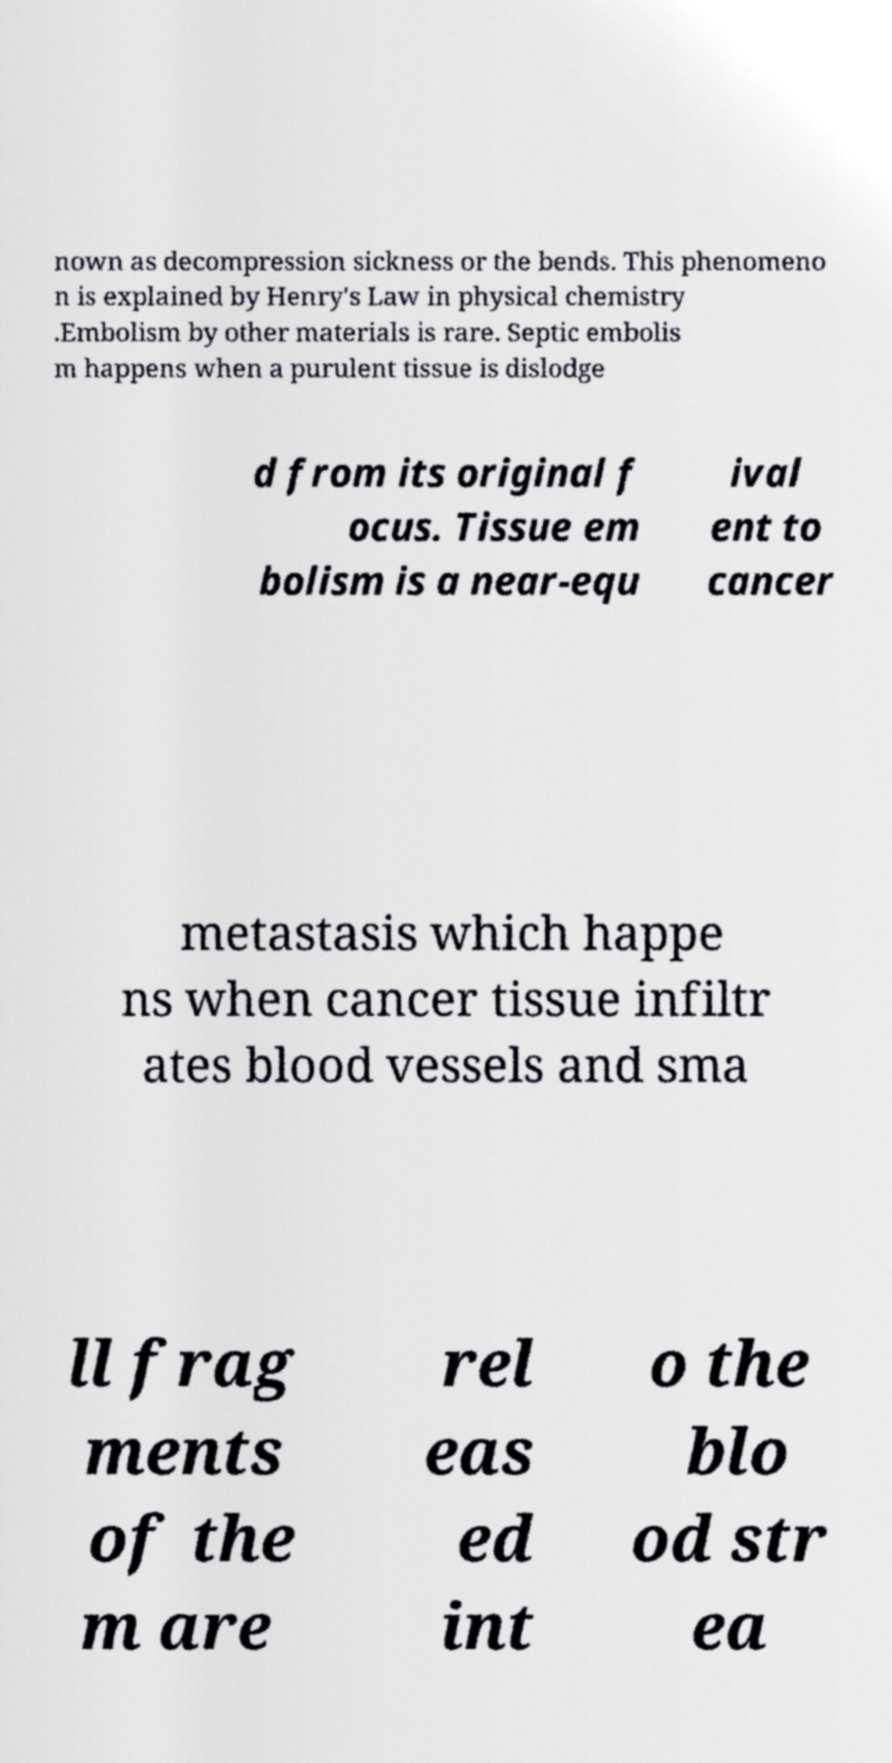What messages or text are displayed in this image? I need them in a readable, typed format. nown as decompression sickness or the bends. This phenomeno n is explained by Henry's Law in physical chemistry .Embolism by other materials is rare. Septic embolis m happens when a purulent tissue is dislodge d from its original f ocus. Tissue em bolism is a near-equ ival ent to cancer metastasis which happe ns when cancer tissue infiltr ates blood vessels and sma ll frag ments of the m are rel eas ed int o the blo od str ea 